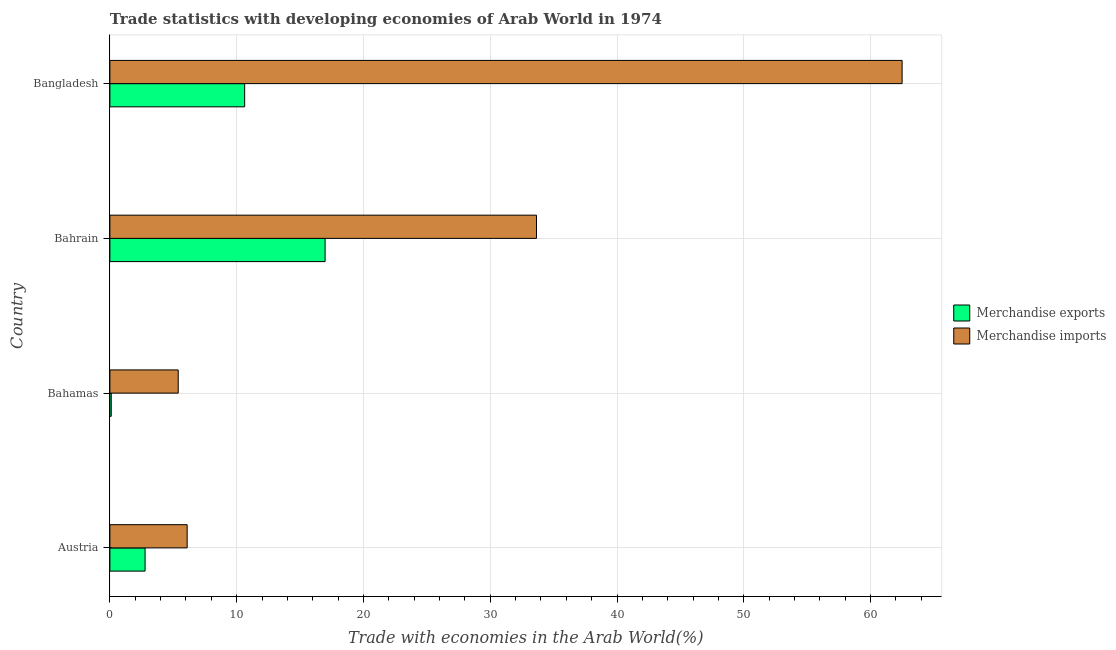How many different coloured bars are there?
Your answer should be compact. 2. Are the number of bars per tick equal to the number of legend labels?
Offer a very short reply. Yes. How many bars are there on the 3rd tick from the bottom?
Provide a succinct answer. 2. What is the label of the 3rd group of bars from the top?
Provide a short and direct response. Bahamas. In how many cases, is the number of bars for a given country not equal to the number of legend labels?
Your answer should be compact. 0. What is the merchandise imports in Bangladesh?
Offer a very short reply. 62.49. Across all countries, what is the maximum merchandise exports?
Offer a very short reply. 16.97. Across all countries, what is the minimum merchandise exports?
Your response must be concise. 0.11. In which country was the merchandise exports maximum?
Make the answer very short. Bahrain. In which country was the merchandise exports minimum?
Your answer should be very brief. Bahamas. What is the total merchandise exports in the graph?
Make the answer very short. 30.49. What is the difference between the merchandise exports in Austria and that in Bahrain?
Give a very brief answer. -14.2. What is the difference between the merchandise exports in Bangladesh and the merchandise imports in Bahrain?
Offer a very short reply. -23.02. What is the average merchandise imports per country?
Give a very brief answer. 26.91. What is the difference between the merchandise imports and merchandise exports in Bahamas?
Your answer should be compact. 5.28. What is the ratio of the merchandise imports in Bahrain to that in Bangladesh?
Your answer should be compact. 0.54. Is the merchandise exports in Bahamas less than that in Bahrain?
Offer a very short reply. Yes. Is the difference between the merchandise exports in Bahamas and Bahrain greater than the difference between the merchandise imports in Bahamas and Bahrain?
Your answer should be compact. Yes. What is the difference between the highest and the second highest merchandise exports?
Keep it short and to the point. 6.34. What is the difference between the highest and the lowest merchandise exports?
Offer a terse response. 16.87. In how many countries, is the merchandise imports greater than the average merchandise imports taken over all countries?
Offer a terse response. 2. What does the 1st bar from the top in Bangladesh represents?
Ensure brevity in your answer.  Merchandise imports. How many countries are there in the graph?
Your answer should be compact. 4. What is the difference between two consecutive major ticks on the X-axis?
Your answer should be compact. 10. Does the graph contain any zero values?
Make the answer very short. No. Does the graph contain grids?
Offer a very short reply. Yes. Where does the legend appear in the graph?
Your answer should be compact. Center right. How many legend labels are there?
Your answer should be very brief. 2. What is the title of the graph?
Offer a very short reply. Trade statistics with developing economies of Arab World in 1974. Does "Female population" appear as one of the legend labels in the graph?
Offer a terse response. No. What is the label or title of the X-axis?
Offer a terse response. Trade with economies in the Arab World(%). What is the Trade with economies in the Arab World(%) in Merchandise exports in Austria?
Keep it short and to the point. 2.78. What is the Trade with economies in the Arab World(%) in Merchandise imports in Austria?
Make the answer very short. 6.09. What is the Trade with economies in the Arab World(%) of Merchandise exports in Bahamas?
Offer a terse response. 0.11. What is the Trade with economies in the Arab World(%) of Merchandise imports in Bahamas?
Ensure brevity in your answer.  5.39. What is the Trade with economies in the Arab World(%) of Merchandise exports in Bahrain?
Provide a short and direct response. 16.97. What is the Trade with economies in the Arab World(%) in Merchandise imports in Bahrain?
Provide a short and direct response. 33.65. What is the Trade with economies in the Arab World(%) in Merchandise exports in Bangladesh?
Make the answer very short. 10.63. What is the Trade with economies in the Arab World(%) of Merchandise imports in Bangladesh?
Ensure brevity in your answer.  62.49. Across all countries, what is the maximum Trade with economies in the Arab World(%) in Merchandise exports?
Your response must be concise. 16.97. Across all countries, what is the maximum Trade with economies in the Arab World(%) of Merchandise imports?
Provide a succinct answer. 62.49. Across all countries, what is the minimum Trade with economies in the Arab World(%) in Merchandise exports?
Your response must be concise. 0.11. Across all countries, what is the minimum Trade with economies in the Arab World(%) of Merchandise imports?
Provide a short and direct response. 5.39. What is the total Trade with economies in the Arab World(%) in Merchandise exports in the graph?
Provide a succinct answer. 30.49. What is the total Trade with economies in the Arab World(%) in Merchandise imports in the graph?
Provide a succinct answer. 107.62. What is the difference between the Trade with economies in the Arab World(%) of Merchandise exports in Austria and that in Bahamas?
Offer a very short reply. 2.67. What is the difference between the Trade with economies in the Arab World(%) in Merchandise imports in Austria and that in Bahamas?
Ensure brevity in your answer.  0.7. What is the difference between the Trade with economies in the Arab World(%) of Merchandise exports in Austria and that in Bahrain?
Give a very brief answer. -14.2. What is the difference between the Trade with economies in the Arab World(%) in Merchandise imports in Austria and that in Bahrain?
Offer a terse response. -27.55. What is the difference between the Trade with economies in the Arab World(%) of Merchandise exports in Austria and that in Bangladesh?
Make the answer very short. -7.85. What is the difference between the Trade with economies in the Arab World(%) in Merchandise imports in Austria and that in Bangladesh?
Ensure brevity in your answer.  -56.39. What is the difference between the Trade with economies in the Arab World(%) in Merchandise exports in Bahamas and that in Bahrain?
Offer a very short reply. -16.87. What is the difference between the Trade with economies in the Arab World(%) in Merchandise imports in Bahamas and that in Bahrain?
Offer a terse response. -28.26. What is the difference between the Trade with economies in the Arab World(%) in Merchandise exports in Bahamas and that in Bangladesh?
Give a very brief answer. -10.52. What is the difference between the Trade with economies in the Arab World(%) of Merchandise imports in Bahamas and that in Bangladesh?
Make the answer very short. -57.1. What is the difference between the Trade with economies in the Arab World(%) of Merchandise exports in Bahrain and that in Bangladesh?
Your response must be concise. 6.34. What is the difference between the Trade with economies in the Arab World(%) of Merchandise imports in Bahrain and that in Bangladesh?
Offer a terse response. -28.84. What is the difference between the Trade with economies in the Arab World(%) in Merchandise exports in Austria and the Trade with economies in the Arab World(%) in Merchandise imports in Bahamas?
Provide a succinct answer. -2.61. What is the difference between the Trade with economies in the Arab World(%) in Merchandise exports in Austria and the Trade with economies in the Arab World(%) in Merchandise imports in Bahrain?
Provide a short and direct response. -30.87. What is the difference between the Trade with economies in the Arab World(%) of Merchandise exports in Austria and the Trade with economies in the Arab World(%) of Merchandise imports in Bangladesh?
Offer a very short reply. -59.71. What is the difference between the Trade with economies in the Arab World(%) in Merchandise exports in Bahamas and the Trade with economies in the Arab World(%) in Merchandise imports in Bahrain?
Ensure brevity in your answer.  -33.54. What is the difference between the Trade with economies in the Arab World(%) of Merchandise exports in Bahamas and the Trade with economies in the Arab World(%) of Merchandise imports in Bangladesh?
Provide a succinct answer. -62.38. What is the difference between the Trade with economies in the Arab World(%) in Merchandise exports in Bahrain and the Trade with economies in the Arab World(%) in Merchandise imports in Bangladesh?
Your answer should be very brief. -45.51. What is the average Trade with economies in the Arab World(%) of Merchandise exports per country?
Keep it short and to the point. 7.62. What is the average Trade with economies in the Arab World(%) in Merchandise imports per country?
Keep it short and to the point. 26.91. What is the difference between the Trade with economies in the Arab World(%) in Merchandise exports and Trade with economies in the Arab World(%) in Merchandise imports in Austria?
Your response must be concise. -3.32. What is the difference between the Trade with economies in the Arab World(%) of Merchandise exports and Trade with economies in the Arab World(%) of Merchandise imports in Bahamas?
Offer a very short reply. -5.28. What is the difference between the Trade with economies in the Arab World(%) in Merchandise exports and Trade with economies in the Arab World(%) in Merchandise imports in Bahrain?
Your response must be concise. -16.67. What is the difference between the Trade with economies in the Arab World(%) of Merchandise exports and Trade with economies in the Arab World(%) of Merchandise imports in Bangladesh?
Your answer should be very brief. -51.86. What is the ratio of the Trade with economies in the Arab World(%) of Merchandise exports in Austria to that in Bahamas?
Ensure brevity in your answer.  26.18. What is the ratio of the Trade with economies in the Arab World(%) of Merchandise imports in Austria to that in Bahamas?
Offer a very short reply. 1.13. What is the ratio of the Trade with economies in the Arab World(%) in Merchandise exports in Austria to that in Bahrain?
Make the answer very short. 0.16. What is the ratio of the Trade with economies in the Arab World(%) in Merchandise imports in Austria to that in Bahrain?
Keep it short and to the point. 0.18. What is the ratio of the Trade with economies in the Arab World(%) in Merchandise exports in Austria to that in Bangladesh?
Provide a succinct answer. 0.26. What is the ratio of the Trade with economies in the Arab World(%) of Merchandise imports in Austria to that in Bangladesh?
Provide a short and direct response. 0.1. What is the ratio of the Trade with economies in the Arab World(%) in Merchandise exports in Bahamas to that in Bahrain?
Offer a terse response. 0.01. What is the ratio of the Trade with economies in the Arab World(%) in Merchandise imports in Bahamas to that in Bahrain?
Ensure brevity in your answer.  0.16. What is the ratio of the Trade with economies in the Arab World(%) in Merchandise imports in Bahamas to that in Bangladesh?
Ensure brevity in your answer.  0.09. What is the ratio of the Trade with economies in the Arab World(%) of Merchandise exports in Bahrain to that in Bangladesh?
Ensure brevity in your answer.  1.6. What is the ratio of the Trade with economies in the Arab World(%) in Merchandise imports in Bahrain to that in Bangladesh?
Provide a short and direct response. 0.54. What is the difference between the highest and the second highest Trade with economies in the Arab World(%) in Merchandise exports?
Your response must be concise. 6.34. What is the difference between the highest and the second highest Trade with economies in the Arab World(%) in Merchandise imports?
Offer a very short reply. 28.84. What is the difference between the highest and the lowest Trade with economies in the Arab World(%) of Merchandise exports?
Give a very brief answer. 16.87. What is the difference between the highest and the lowest Trade with economies in the Arab World(%) of Merchandise imports?
Provide a short and direct response. 57.1. 